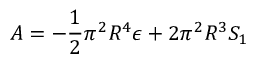<formula> <loc_0><loc_0><loc_500><loc_500>A = - \frac { 1 } { 2 } \pi ^ { 2 } R ^ { 4 } \epsilon + 2 \pi ^ { 2 } R ^ { 3 } S _ { 1 }</formula> 